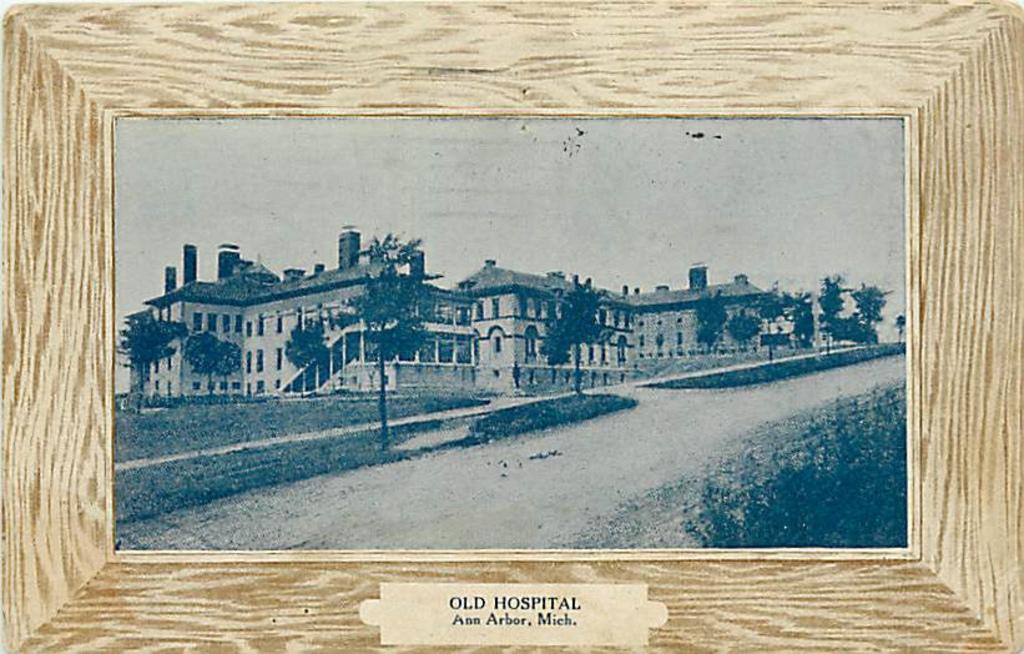What city is this in?
Offer a very short reply. Ann arbor. What building is this a picture of?
Your response must be concise. Old hospital. 